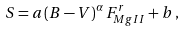<formula> <loc_0><loc_0><loc_500><loc_500>S = a \, ( B - V ) ^ { \alpha } \, F ^ { r } _ { M g I I } + b \, ,</formula> 